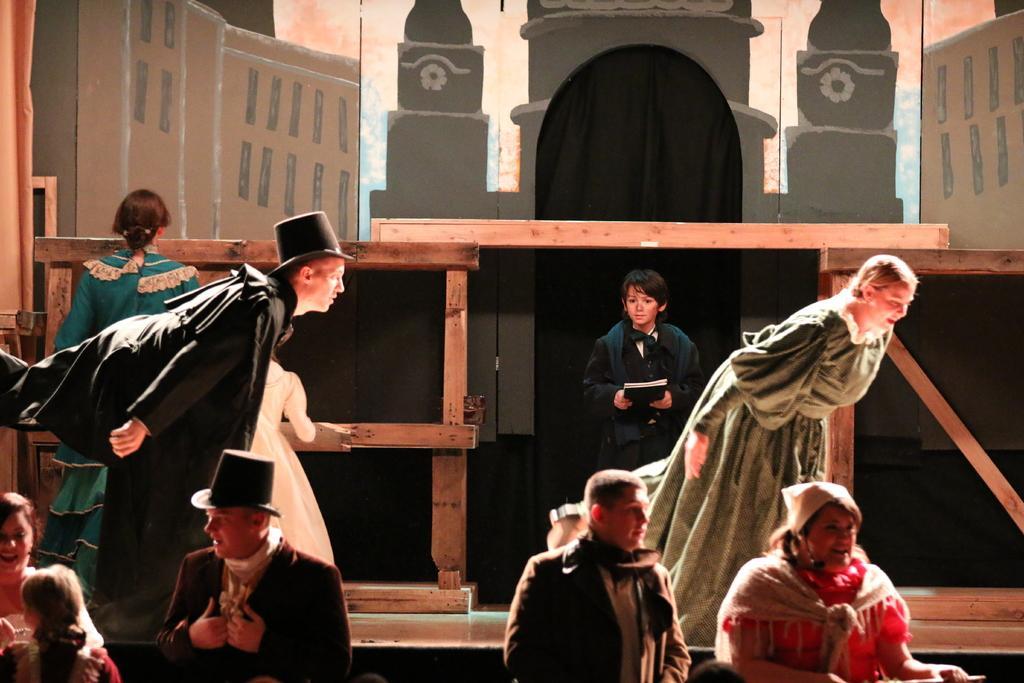Can you describe this image briefly? There are people in the foreground area of the image, it seems like they are dancing, there are is a boy holding a book, painting on the stage and wooden planks and a girl in the background. 